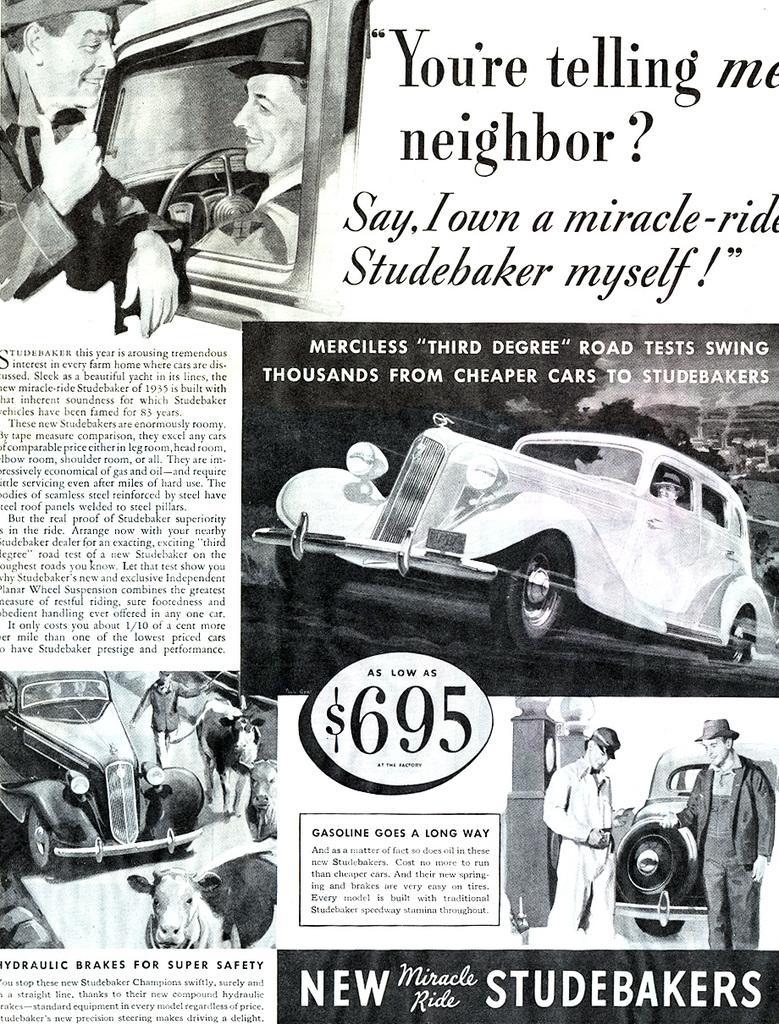Describe this image in one or two sentences. In the image we can see a poster. In the poster we can see some text and vehicles and few people are standing and sitting. 